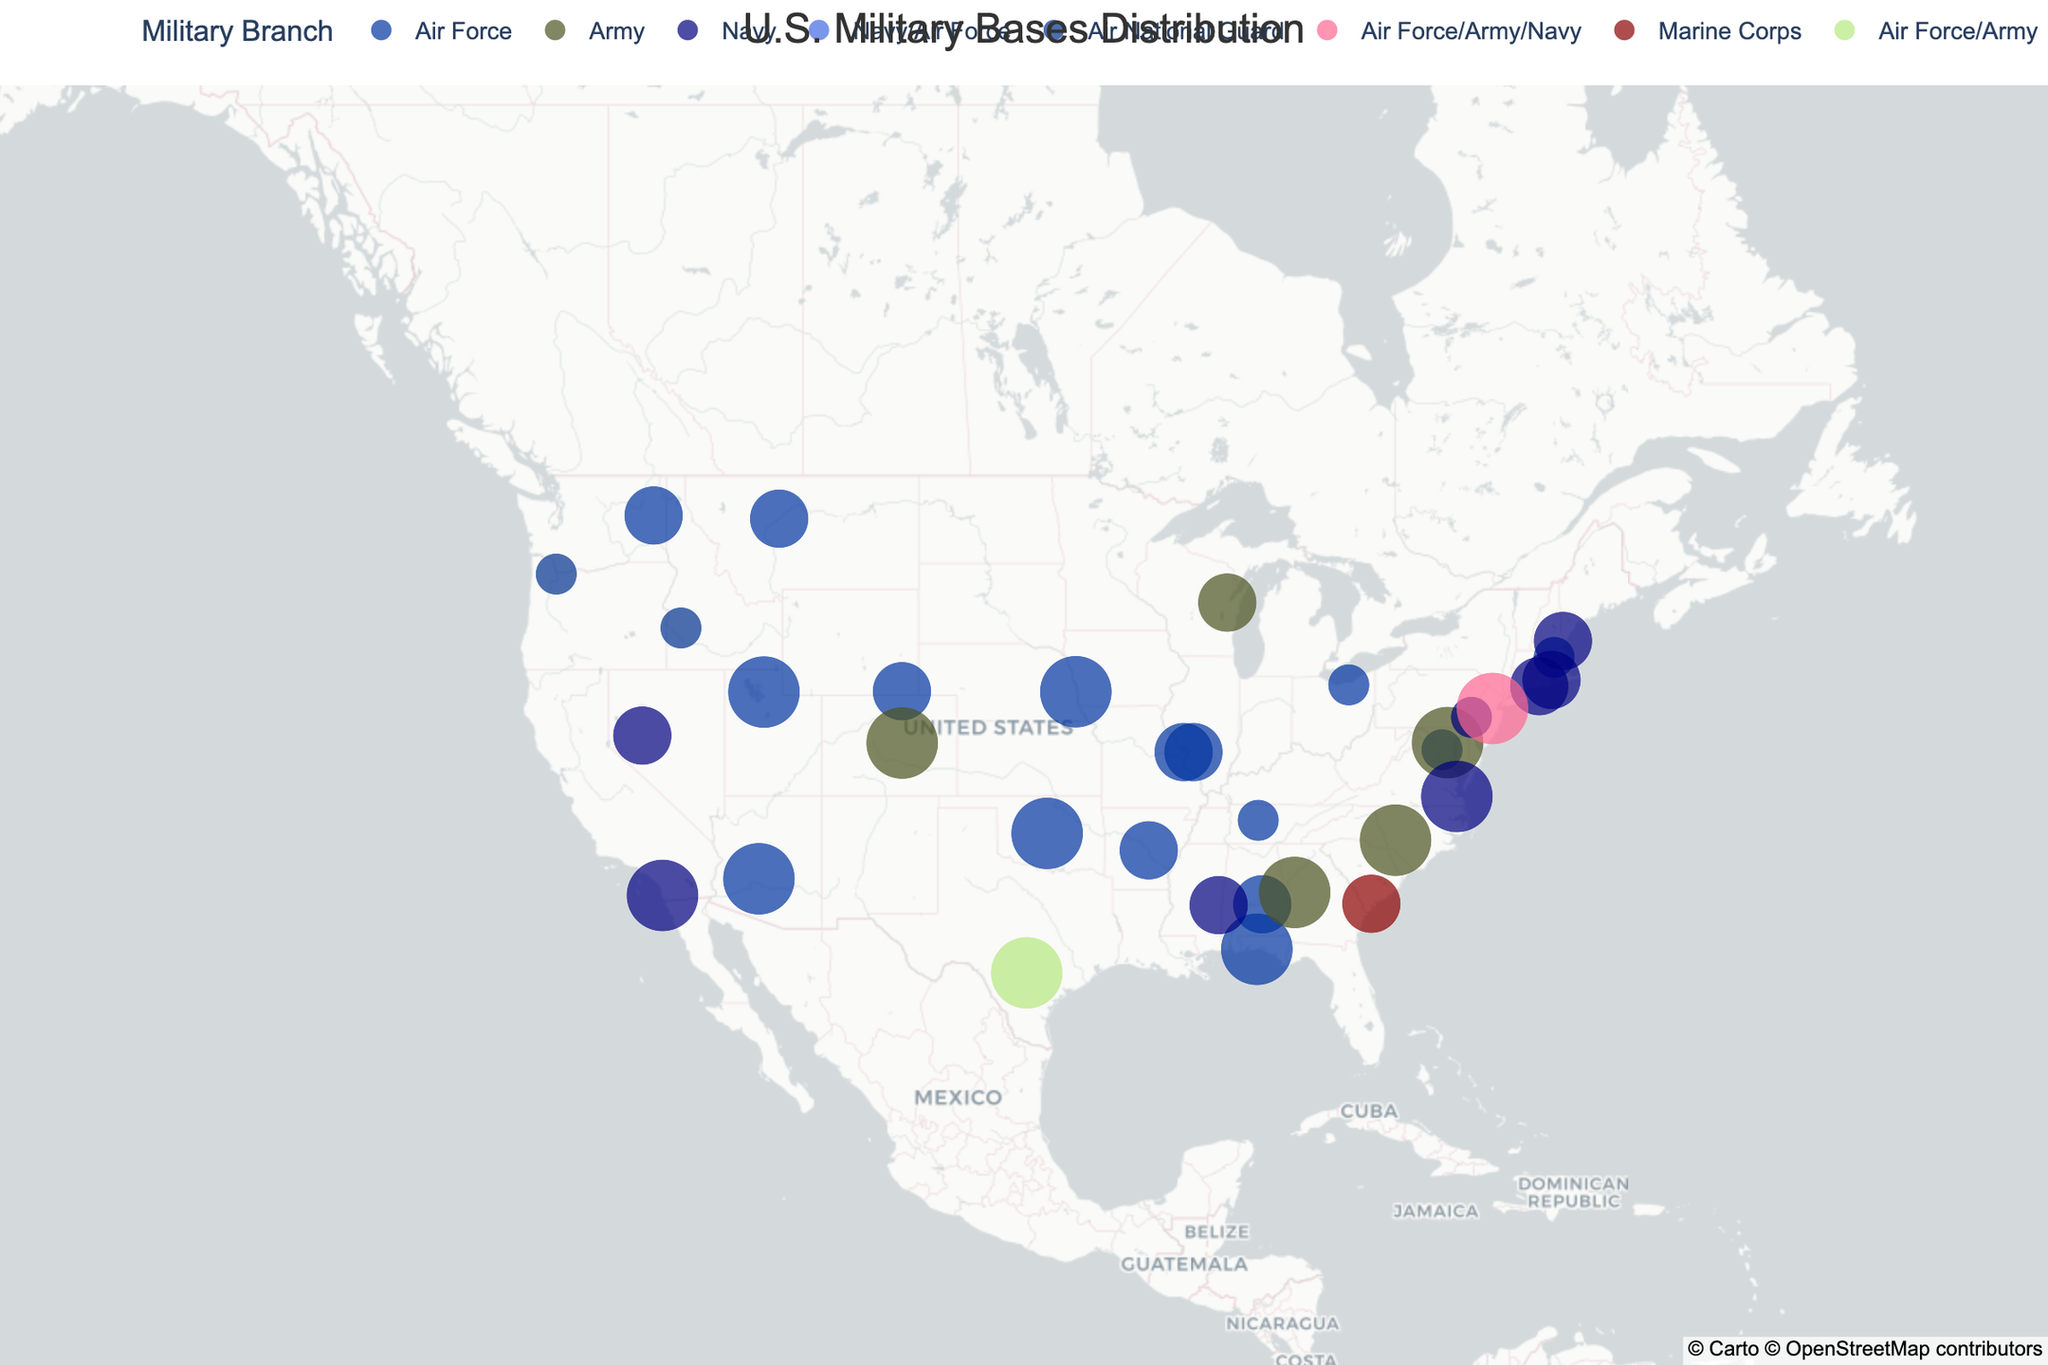Which military branch has the highest number of bases on the map? By glancing at the color distribution on the map, we can see that the Air Force (represented in blue) has the highest number of markers compared to other colors.
Answer: Air Force What is the marker size for a large military base? By referring to the legend or the size of the markers, large military bases are represented by the largest marker sizing 30.
Answer: 30 How many military bases are located in California? By locating California on the map, we observe that there is one military base represented by the marker at the coordinates attributable to the state.
Answer: 1 Which state has the largest concentration of military bases? By scanning the map for the state with the highest number of markers, Texas and California can be compared. Texas has multiple markers while California has fewer. Therefore, Texas has the largest concentration.
Answer: Texas What is the primary color used for Army bases on the map? By looking at the color representation of the Army on the legend and the markers, Army bases are shown in green.
Answer: Green Which base is located the furthest north? By inspecting the base location points, the furthest north marker is in Alaska, representing Fort Wainwright.
Answer: Fort Wainwright Where is the Naval Base San Diego located? (State) By finding Naval Base San Diego on the map, its tooltip, or referring to California, where its marker is located.
Answer: California Which branches share the Joint Base Pearl Harbor-Hickam? By observing the tooltip or hover data for Joint Base Pearl Harbor-Hickam, we see that it is shared by the Navy and Air Force.
Answer: Navy and Air Force How many medium-sized Navy bases are there in the United States? By identifying medium-sized markers and cross-referencing with the navy color on the map, we count multiple instances.
Answer: 7 